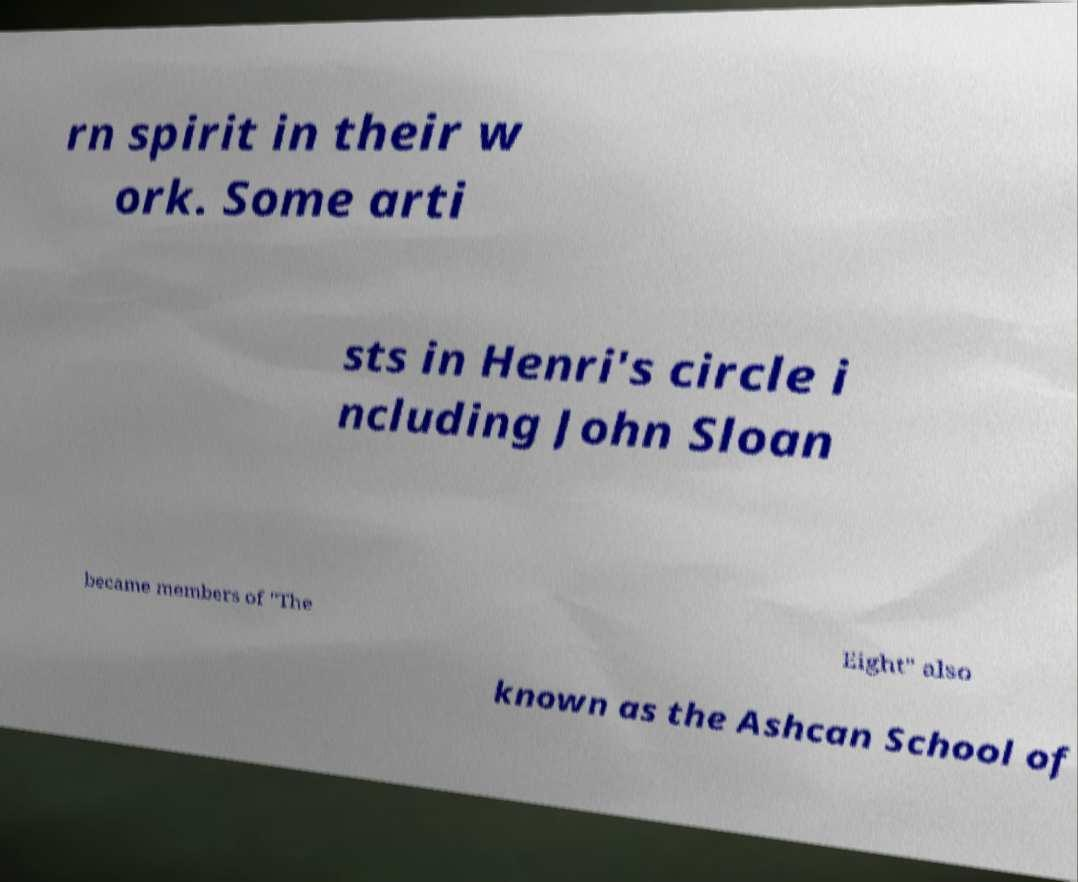Can you accurately transcribe the text from the provided image for me? rn spirit in their w ork. Some arti sts in Henri's circle i ncluding John Sloan became members of "The Eight" also known as the Ashcan School of 